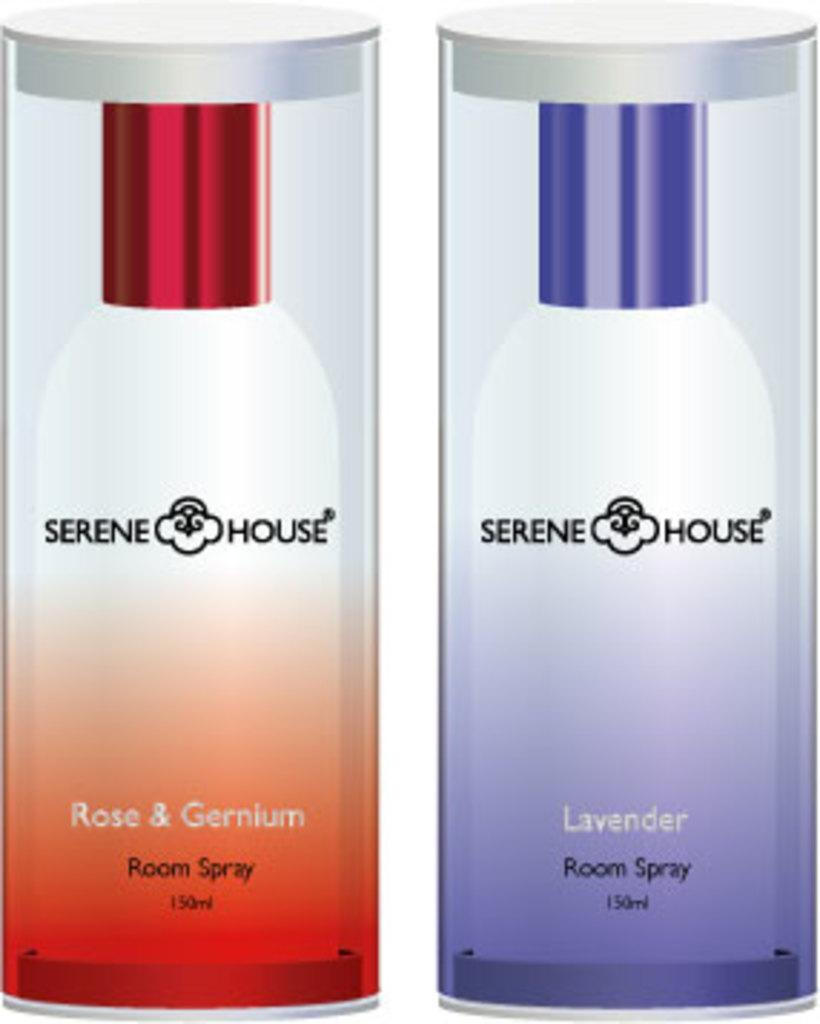Provide a one-sentence caption for the provided image. Two different scents of Serene House room spray are next to each other. 